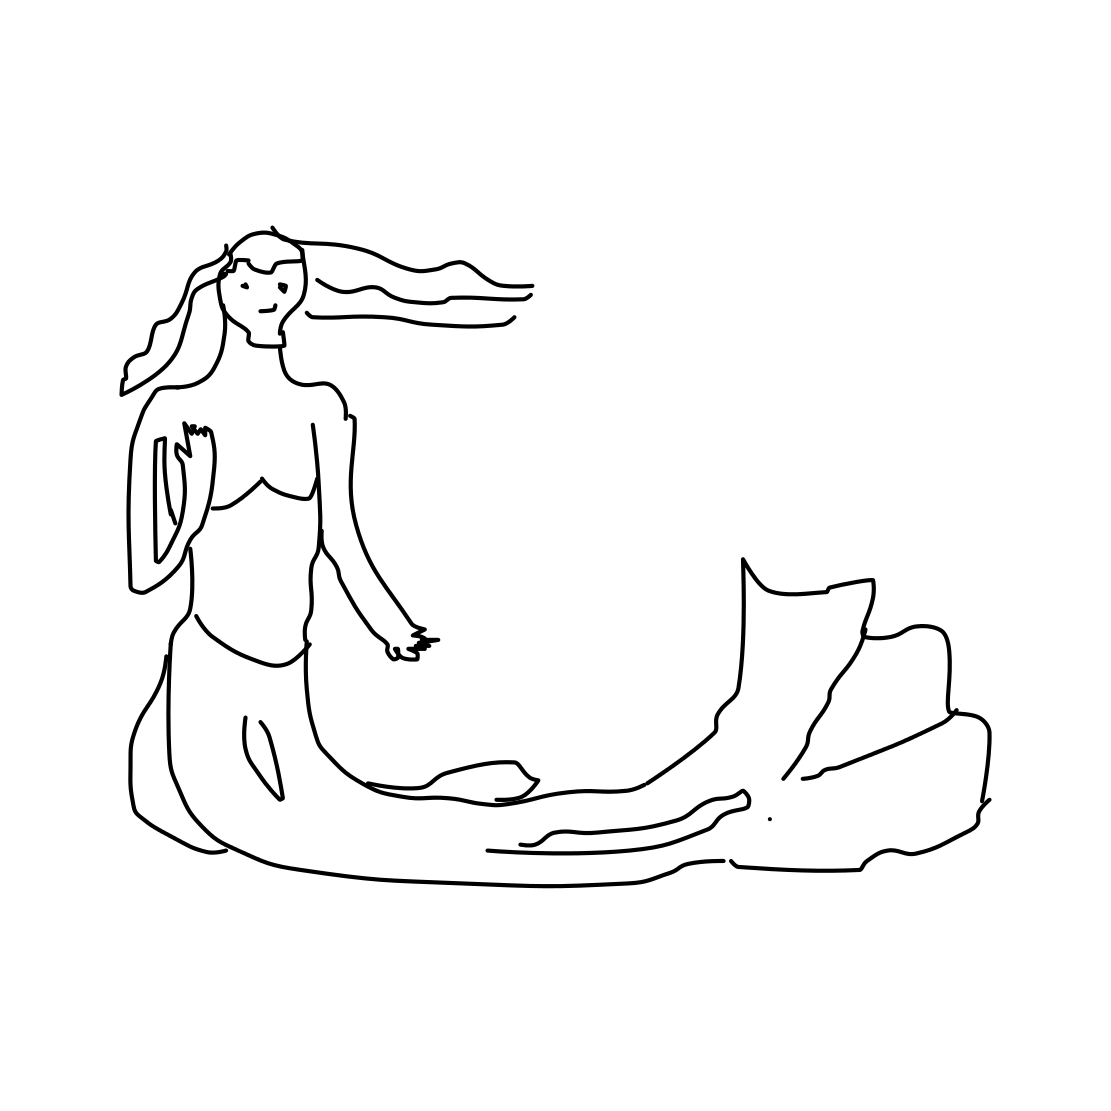Can you describe what the figure represents in this image? The image portrays a mermaid, a mythical sea creature with the upper body of a human and the tail of a fish, sitting on a rock. What mood does the image evoke? The image evokes a sense of calm and serenity, possibly reflecting the peaceful nature typically associated with underwater themes. 